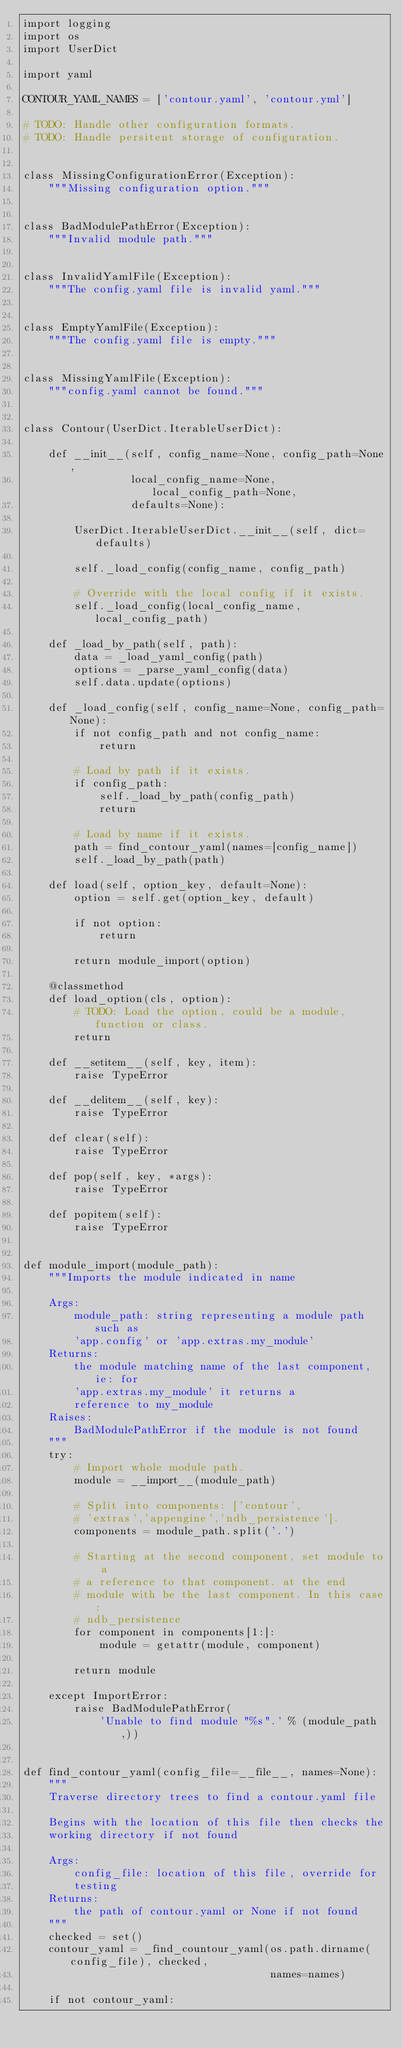Convert code to text. <code><loc_0><loc_0><loc_500><loc_500><_Python_>import logging
import os
import UserDict

import yaml

CONTOUR_YAML_NAMES = ['contour.yaml', 'contour.yml']

# TODO: Handle other configuration formats.
# TODO: Handle persitent storage of configuration.


class MissingConfigurationError(Exception):
    """Missing configuration option."""


class BadModulePathError(Exception):
    """Invalid module path."""


class InvalidYamlFile(Exception):
    """The config.yaml file is invalid yaml."""


class EmptyYamlFile(Exception):
    """The config.yaml file is empty."""


class MissingYamlFile(Exception):
    """config.yaml cannot be found."""


class Contour(UserDict.IterableUserDict):

    def __init__(self, config_name=None, config_path=None,
                 local_config_name=None, local_config_path=None,
                 defaults=None):

        UserDict.IterableUserDict.__init__(self, dict=defaults)

        self._load_config(config_name, config_path)

        # Override with the local config if it exists.
        self._load_config(local_config_name, local_config_path)

    def _load_by_path(self, path):
        data = _load_yaml_config(path)
        options = _parse_yaml_config(data)
        self.data.update(options)

    def _load_config(self, config_name=None, config_path=None):
        if not config_path and not config_name:
            return

        # Load by path if it exists.
        if config_path:
            self._load_by_path(config_path)
            return

        # Load by name if it exists.
        path = find_contour_yaml(names=[config_name])
        self._load_by_path(path)

    def load(self, option_key, default=None):
        option = self.get(option_key, default)

        if not option:
            return

        return module_import(option)

    @classmethod
    def load_option(cls, option):
        # TODO: Load the option, could be a module, function or class.
        return

    def __setitem__(self, key, item):
        raise TypeError

    def __delitem__(self, key):
        raise TypeError

    def clear(self):
        raise TypeError

    def pop(self, key, *args):
        raise TypeError

    def popitem(self):
        raise TypeError


def module_import(module_path):
    """Imports the module indicated in name

    Args:
        module_path: string representing a module path such as
        'app.config' or 'app.extras.my_module'
    Returns:
        the module matching name of the last component, ie: for
        'app.extras.my_module' it returns a
        reference to my_module
    Raises:
        BadModulePathError if the module is not found
    """
    try:
        # Import whole module path.
        module = __import__(module_path)

        # Split into components: ['contour',
        # 'extras','appengine','ndb_persistence'].
        components = module_path.split('.')

        # Starting at the second component, set module to a
        # a reference to that component. at the end
        # module with be the last component. In this case:
        # ndb_persistence
        for component in components[1:]:
            module = getattr(module, component)

        return module

    except ImportError:
        raise BadModulePathError(
            'Unable to find module "%s".' % (module_path,))


def find_contour_yaml(config_file=__file__, names=None):
    """
    Traverse directory trees to find a contour.yaml file

    Begins with the location of this file then checks the
    working directory if not found

    Args:
        config_file: location of this file, override for
        testing
    Returns:
        the path of contour.yaml or None if not found
    """
    checked = set()
    contour_yaml = _find_countour_yaml(os.path.dirname(config_file), checked,
                                       names=names)

    if not contour_yaml:</code> 